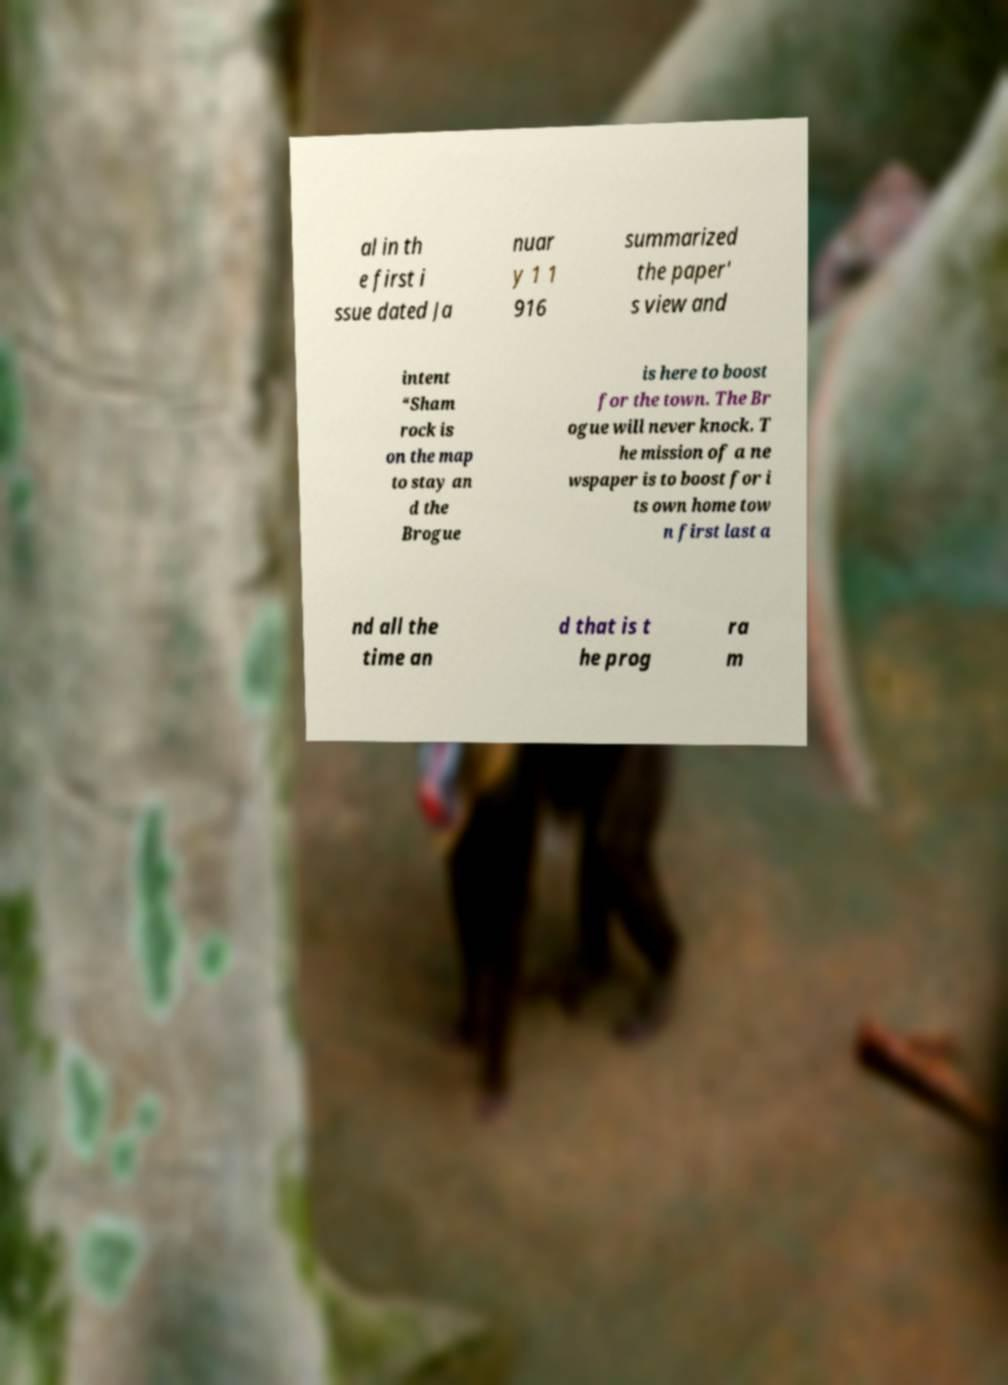What messages or text are displayed in this image? I need them in a readable, typed format. al in th e first i ssue dated Ja nuar y 1 1 916 summarized the paper' s view and intent “Sham rock is on the map to stay an d the Brogue is here to boost for the town. The Br ogue will never knock. T he mission of a ne wspaper is to boost for i ts own home tow n first last a nd all the time an d that is t he prog ra m 